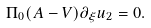<formula> <loc_0><loc_0><loc_500><loc_500>\Pi _ { 0 } ( A - V ) \partial _ { \xi } u _ { 2 } = 0 .</formula> 